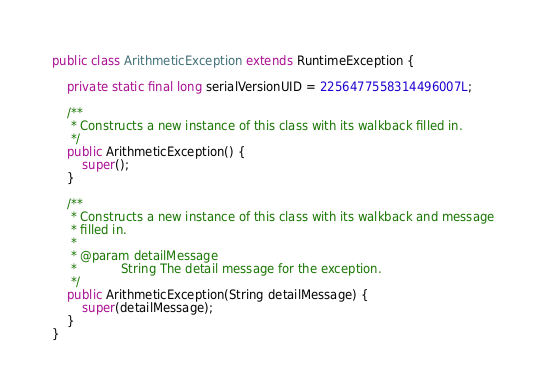<code> <loc_0><loc_0><loc_500><loc_500><_Java_>public class ArithmeticException extends RuntimeException {

    private static final long serialVersionUID = 2256477558314496007L;

    /**
     * Constructs a new instance of this class with its walkback filled in.
     */
    public ArithmeticException() {
        super();
    }

    /**
     * Constructs a new instance of this class with its walkback and message
     * filled in.
     * 
     * @param detailMessage
     *            String The detail message for the exception.
     */
    public ArithmeticException(String detailMessage) {
        super(detailMessage);
    }
}
</code> 